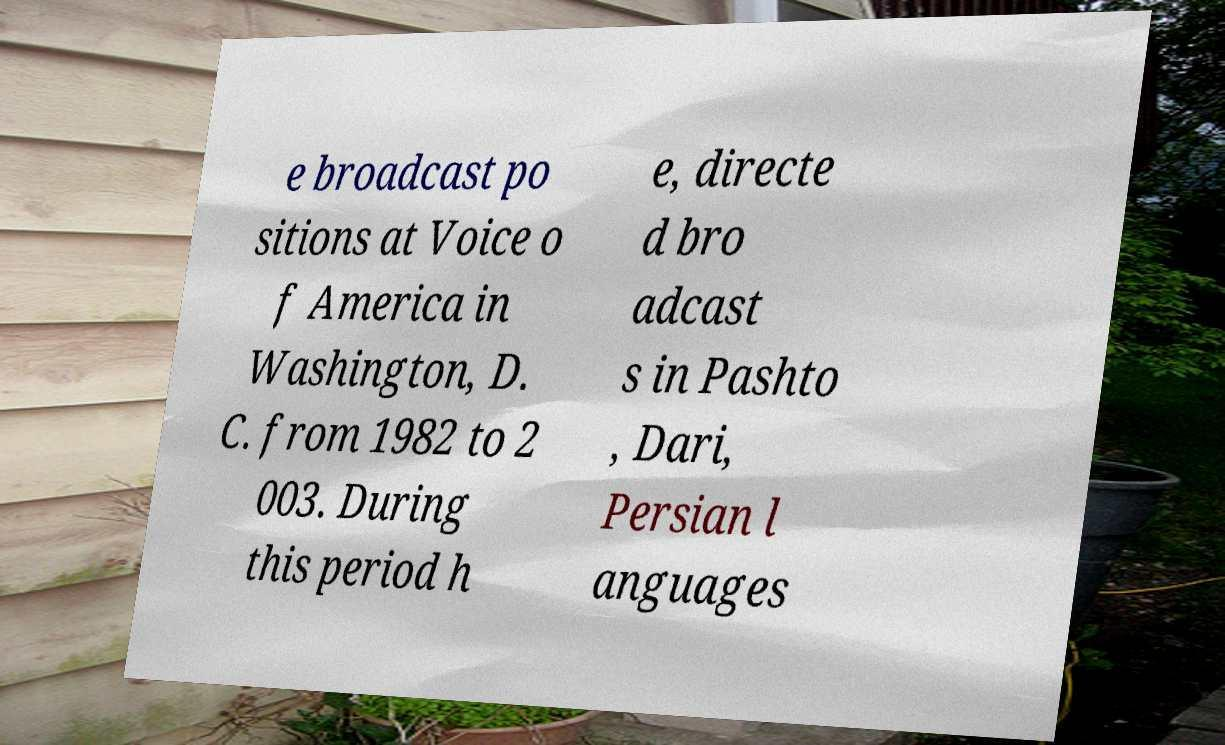Please identify and transcribe the text found in this image. e broadcast po sitions at Voice o f America in Washington, D. C. from 1982 to 2 003. During this period h e, directe d bro adcast s in Pashto , Dari, Persian l anguages 